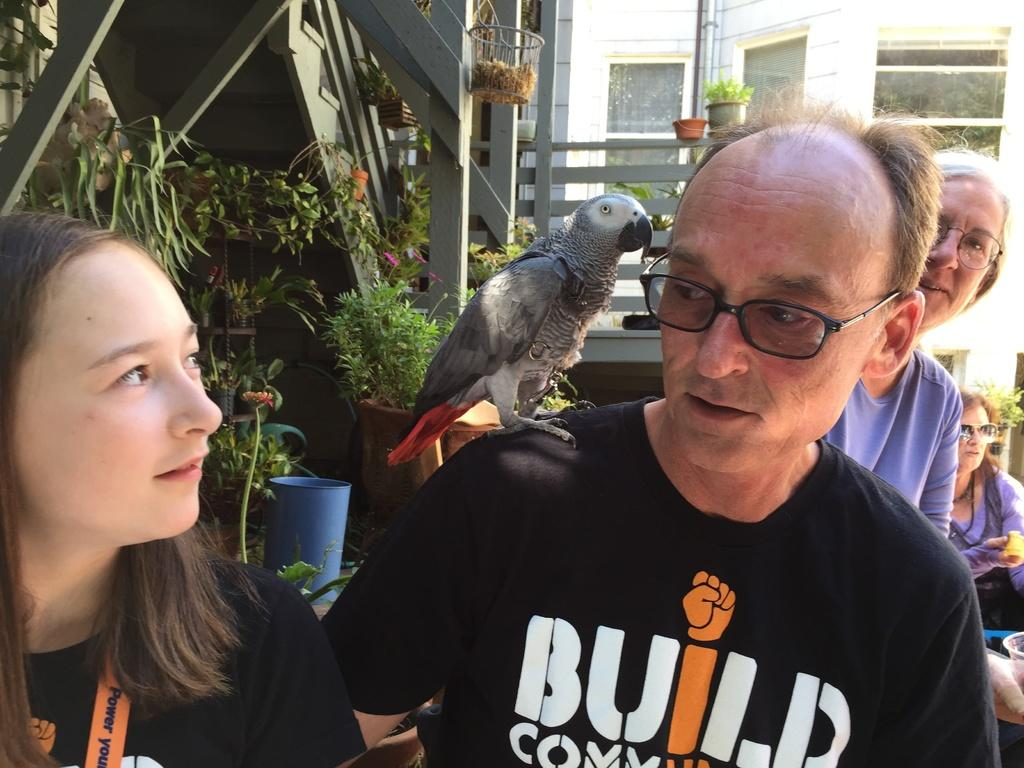How many people are in the image? There are people in the image, but the exact number is not specified. What is the bird doing in the image? A bird is standing on the shoulders of one person in the image. What architectural features can be seen in the background of the image? In the background of the image, there are stairs, railings, flower pots, and buildings. What type of tray is being used by the friend in the image? There is no mention of a tray or a friend in the image. The image features people, a bird, and various architectural features in the background. 